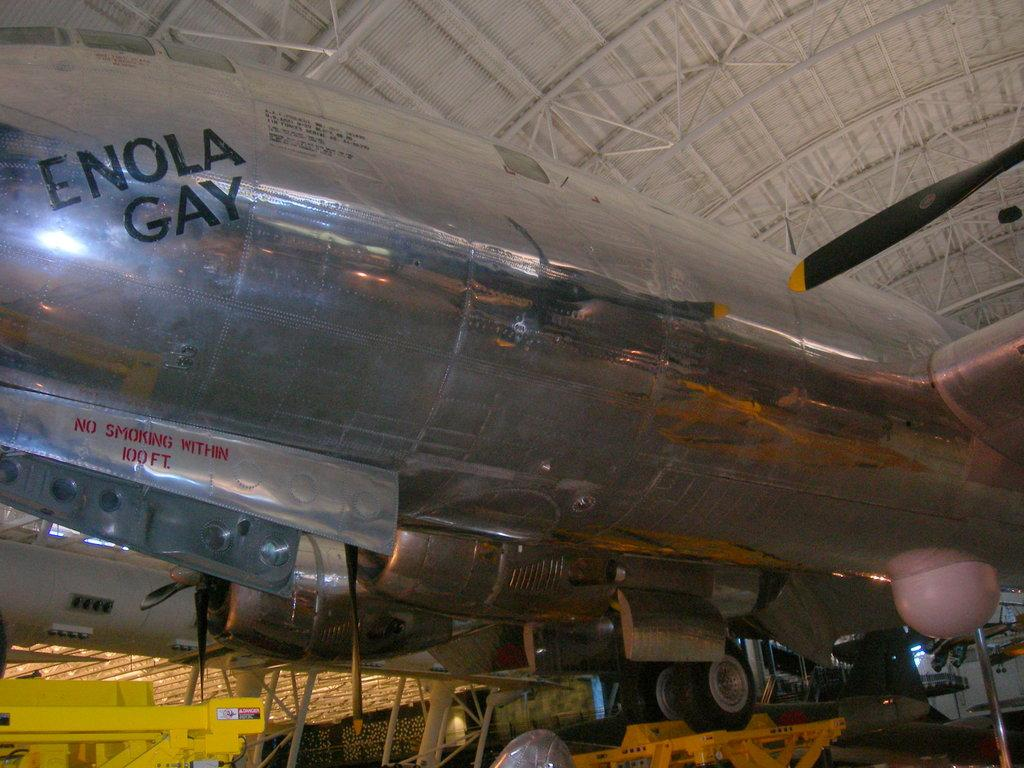<image>
Create a compact narrative representing the image presented. a silver aircraft parked in a building with the writing enola gay on the top 